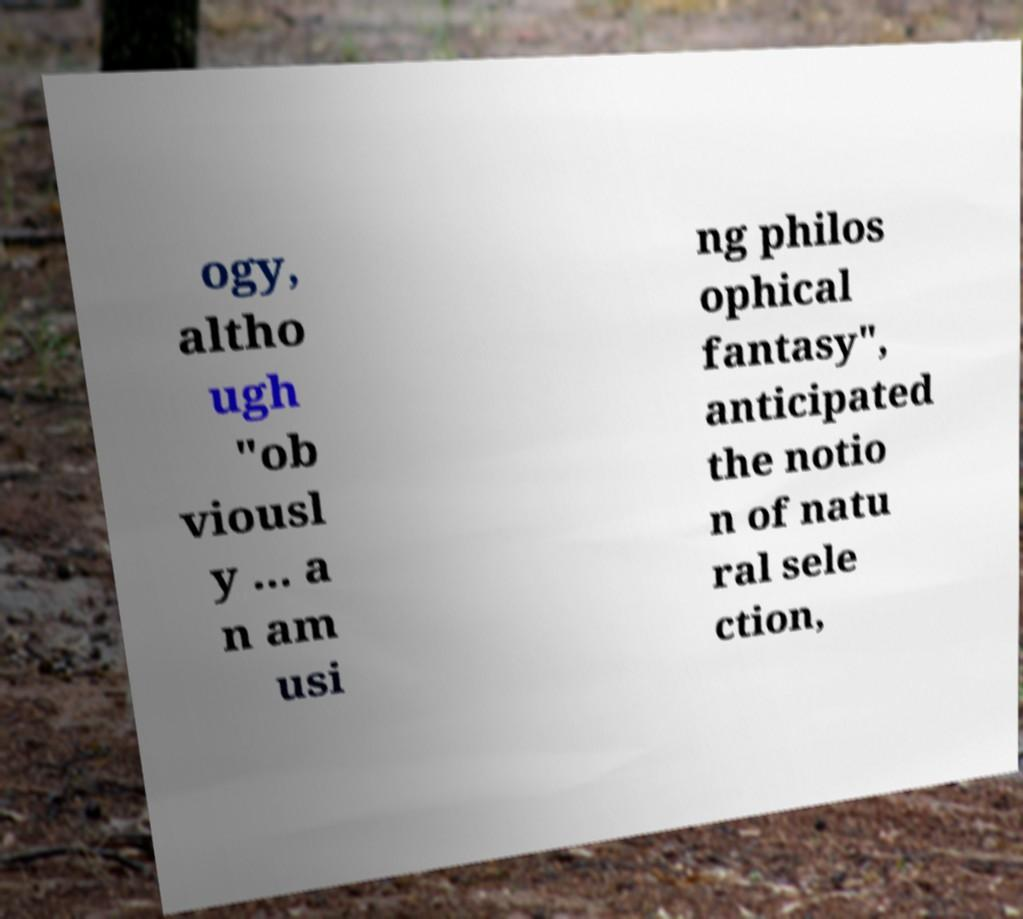I need the written content from this picture converted into text. Can you do that? ogy, altho ugh "ob viousl y ... a n am usi ng philos ophical fantasy", anticipated the notio n of natu ral sele ction, 